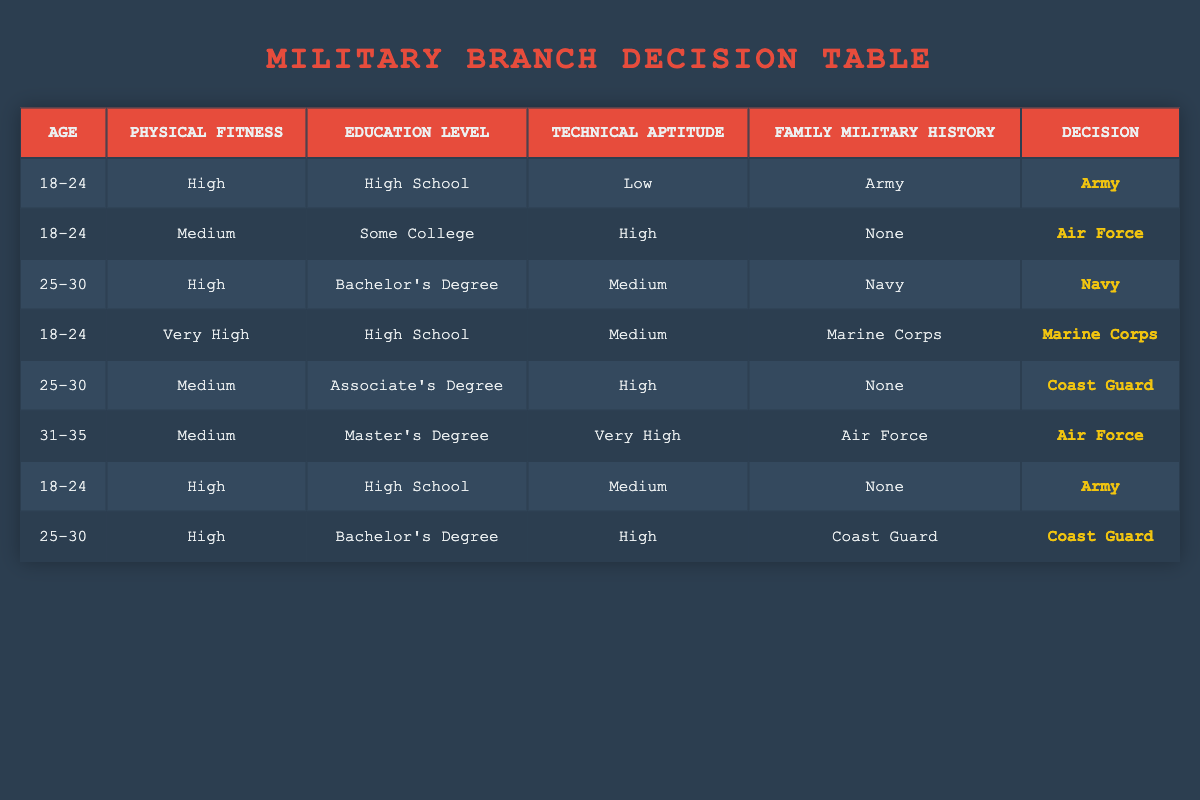What military branch is recommended for recruits aged 18-24 with high physical fitness, a high school education, and a family military history in the Army? According to the table, this specific set of conditions matches the first rule, which states that if the recruit is 18-24 years old, has high physical fitness, graduated high school, has low technical aptitude, and comes from a family with a military history in the Army, the decision is to join the Army.
Answer: Army Which military branch is chosen by recruits aged 25-30 with a bachelor’s degree, medium technical aptitude, and a family history in the Navy? This information aligns with the third rule in the table, where it states that recruits aged 25-30, who are physically fit (High), hold a bachelor's degree, possess medium technical aptitude, and have a Navy family military history will select the Navy.
Answer: Navy Is it true that recruits aged 18-24 with very high physical fitness and a family history in the Marine Corps will choose the Marine Corps? The table shows that recruits aged 18-24 with very high physical fitness, a high school education, medium technical aptitude, and a family military history in the Marine Corps indeed lead to a decision to join the Marine Corps, confirming that the statement is true.
Answer: Yes What is the decision for recruits aged 31-35 with a master's degree, medium physical fitness, and very high technical aptitude, who have a family history in the Air Force? In this case, the rule for recruits aged 31-35 states that they would join the Air Force if they are medium in physical fitness, have a master's degree, very high technical aptitude, and a family history in the Air Force, which clearly shows that the decision is to join the Air Force.
Answer: Air Force How many entries in the table correspond to recruits aged 25-30? By inspecting the table, there are three rows corresponding to recruits aged 25-30: one for a high physical fitness level with a bachelor's degree and a Navy family military history, one for medium fitness with an associate's degree and no family history, and one with high fitness and a bachelor's degree, belonging to a Coast Guard family. Therefore, the count is 3.
Answer: 3 Are there any recruits in the table who have a high school education level and low technical aptitude? After reviewing the table, we find that two recruits aged 18-24 are listed with high school education: one has low technical aptitude and one has medium. Thus, it is accurate to state that yes, there is a recruit with a high school education and low technical aptitude in the table.
Answer: Yes Which military branch is selected by the eligible recruit with an associate's degree, medium physical fitness, and high technical aptitude whose family has no military history? The table indicates that a recruit aged 25-30 meets these criteria and will join the Coast Guard based on the corresponding rule. Thus, the military branch selected is the Coast Guard.
Answer: Coast Guard How many recruits in the table have a specified physical fitness level of "High"? By counting all the entries in the table, we find four rules that mention "High" in the physical fitness category: the first, the third, the sixth, and the seventh entries. Hence, the total number of recruits with a high physical fitness level is 4.
Answer: 4 